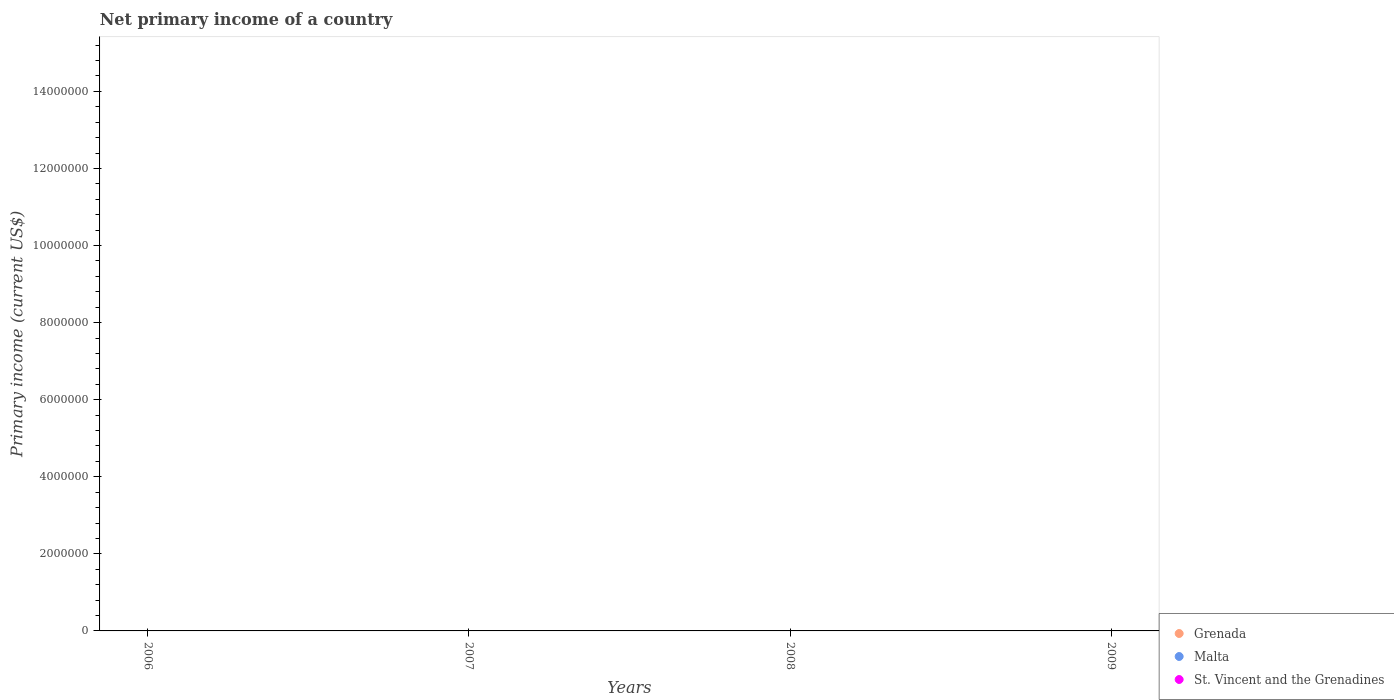Across all years, what is the minimum primary income in Grenada?
Ensure brevity in your answer.  0. What is the average primary income in Malta per year?
Provide a succinct answer. 0. Does the primary income in St. Vincent and the Grenadines monotonically increase over the years?
Provide a succinct answer. No. Is the primary income in Malta strictly greater than the primary income in St. Vincent and the Grenadines over the years?
Provide a succinct answer. No. Is the primary income in Grenada strictly less than the primary income in Malta over the years?
Your answer should be compact. No. How many dotlines are there?
Give a very brief answer. 0. How many years are there in the graph?
Your answer should be very brief. 4. Does the graph contain any zero values?
Keep it short and to the point. Yes. Does the graph contain grids?
Provide a short and direct response. No. How many legend labels are there?
Keep it short and to the point. 3. How are the legend labels stacked?
Your answer should be very brief. Vertical. What is the title of the graph?
Your answer should be compact. Net primary income of a country. What is the label or title of the Y-axis?
Provide a succinct answer. Primary income (current US$). What is the Primary income (current US$) in Grenada in 2009?
Make the answer very short. 0. What is the Primary income (current US$) in St. Vincent and the Grenadines in 2009?
Keep it short and to the point. 0. What is the total Primary income (current US$) in Malta in the graph?
Give a very brief answer. 0. What is the total Primary income (current US$) of St. Vincent and the Grenadines in the graph?
Ensure brevity in your answer.  0. What is the average Primary income (current US$) in Malta per year?
Your answer should be very brief. 0. 